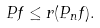Convert formula to latex. <formula><loc_0><loc_0><loc_500><loc_500>P f \leq r ( P _ { n } f ) .</formula> 